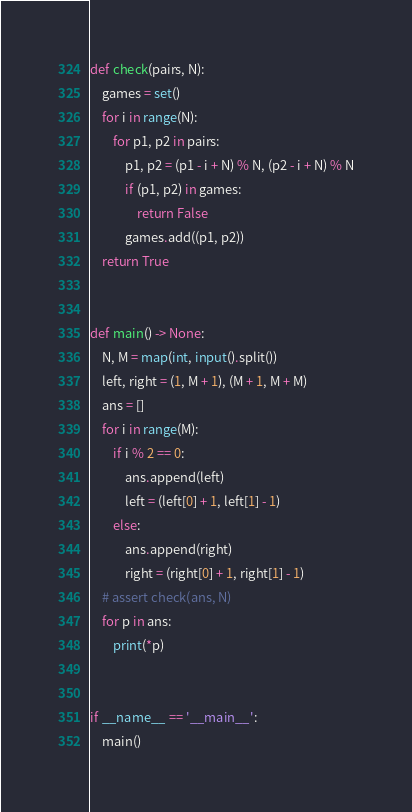<code> <loc_0><loc_0><loc_500><loc_500><_Python_>def check(pairs, N):
    games = set()
    for i in range(N):
        for p1, p2 in pairs:
            p1, p2 = (p1 - i + N) % N, (p2 - i + N) % N
            if (p1, p2) in games:
                return False
            games.add((p1, p2))
    return True


def main() -> None:
    N, M = map(int, input().split())
    left, right = (1, M + 1), (M + 1, M + M)
    ans = []
    for i in range(M):
        if i % 2 == 0:
            ans.append(left)
            left = (left[0] + 1, left[1] - 1)
        else:
            ans.append(right)
            right = (right[0] + 1, right[1] - 1)
    # assert check(ans, N)
    for p in ans:
        print(*p)


if __name__ == '__main__':
    main()
</code> 